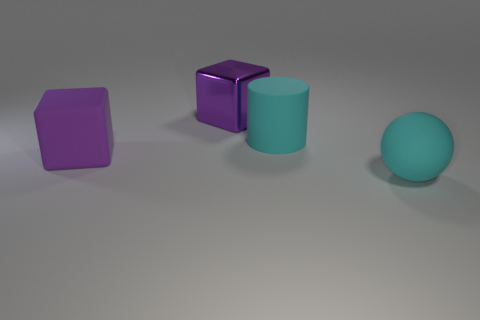Subtract all spheres. How many objects are left? 3 Add 4 rubber balls. How many objects exist? 8 Subtract 1 cylinders. How many cylinders are left? 0 Subtract all green blocks. How many gray cylinders are left? 0 Subtract all big cylinders. Subtract all large cyan balls. How many objects are left? 2 Add 1 big balls. How many big balls are left? 2 Add 3 big yellow rubber cylinders. How many big yellow rubber cylinders exist? 3 Subtract 0 blue cylinders. How many objects are left? 4 Subtract all blue blocks. Subtract all green cylinders. How many blocks are left? 2 